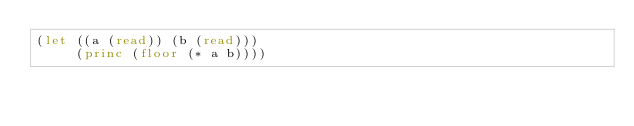<code> <loc_0><loc_0><loc_500><loc_500><_Lisp_>(let ((a (read)) (b (read)))
     (princ (floor (* a b))))</code> 